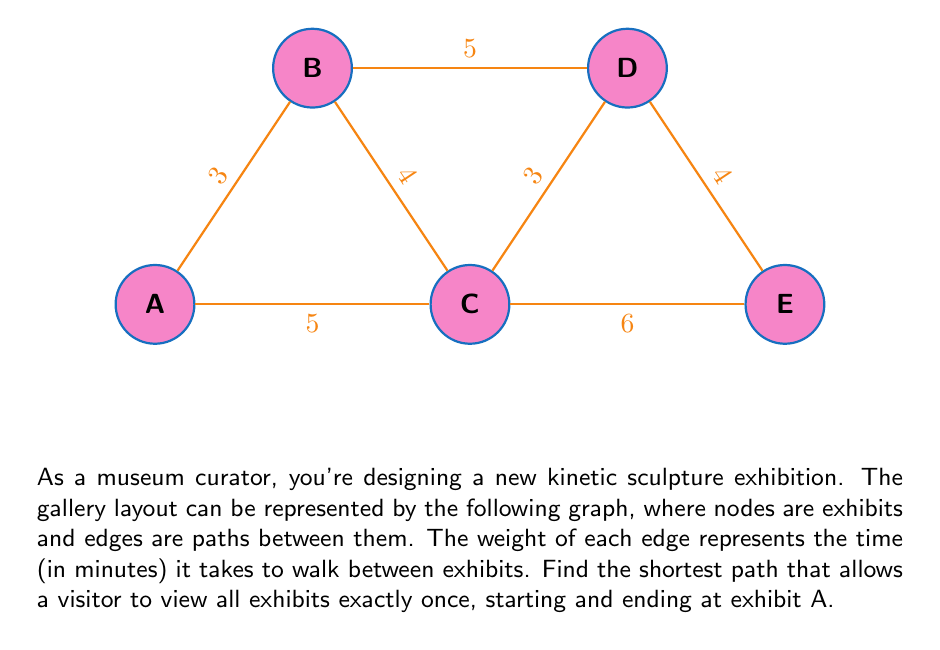Teach me how to tackle this problem. To solve this problem, we need to find the Hamiltonian cycle with the minimum total weight in the given graph. This is known as the Traveling Salesman Problem (TSP), which is NP-hard. For small graphs like this, we can solve it by systematically checking all possible paths.

Step 1: List all possible Hamiltonian cycles starting and ending at A.
1. A-B-C-D-E-A
2. A-B-D-C-E-A
3. A-C-B-D-E-A
4. A-C-D-B-E-A
5. A-C-E-D-B-A

Step 2: Calculate the total weight (time) for each path.

1. A-B-C-D-E-A = 3 + 4 + 3 + 4 + 6 = 20
2. A-B-D-C-E-A = 3 + 5 + 3 + 4 + 6 = 21
3. A-C-B-D-E-A = 5 + 4 + 5 + 4 + 6 = 24
4. A-C-D-B-E-A = 5 + 3 + 5 + 4 + 6 = 23
5. A-C-E-D-B-A = 5 + 6 + 4 + 5 + 3 = 23

Step 3: Identify the path with the minimum total weight.

The shortest path is A-B-C-D-E-A with a total time of 20 minutes.

This solution ensures that visitors can efficiently view all kinetic sculptures in the exhibition while minimizing walking time, allowing them to focus more on appreciating the artistic and scientific aspects of the displays.
Answer: A-B-C-D-E-A, 20 minutes 